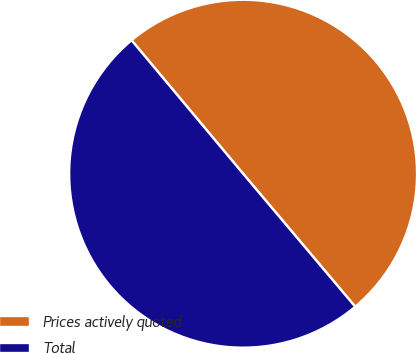<chart> <loc_0><loc_0><loc_500><loc_500><pie_chart><fcel>Prices actively quoted<fcel>Total<nl><fcel>49.93%<fcel>50.07%<nl></chart> 